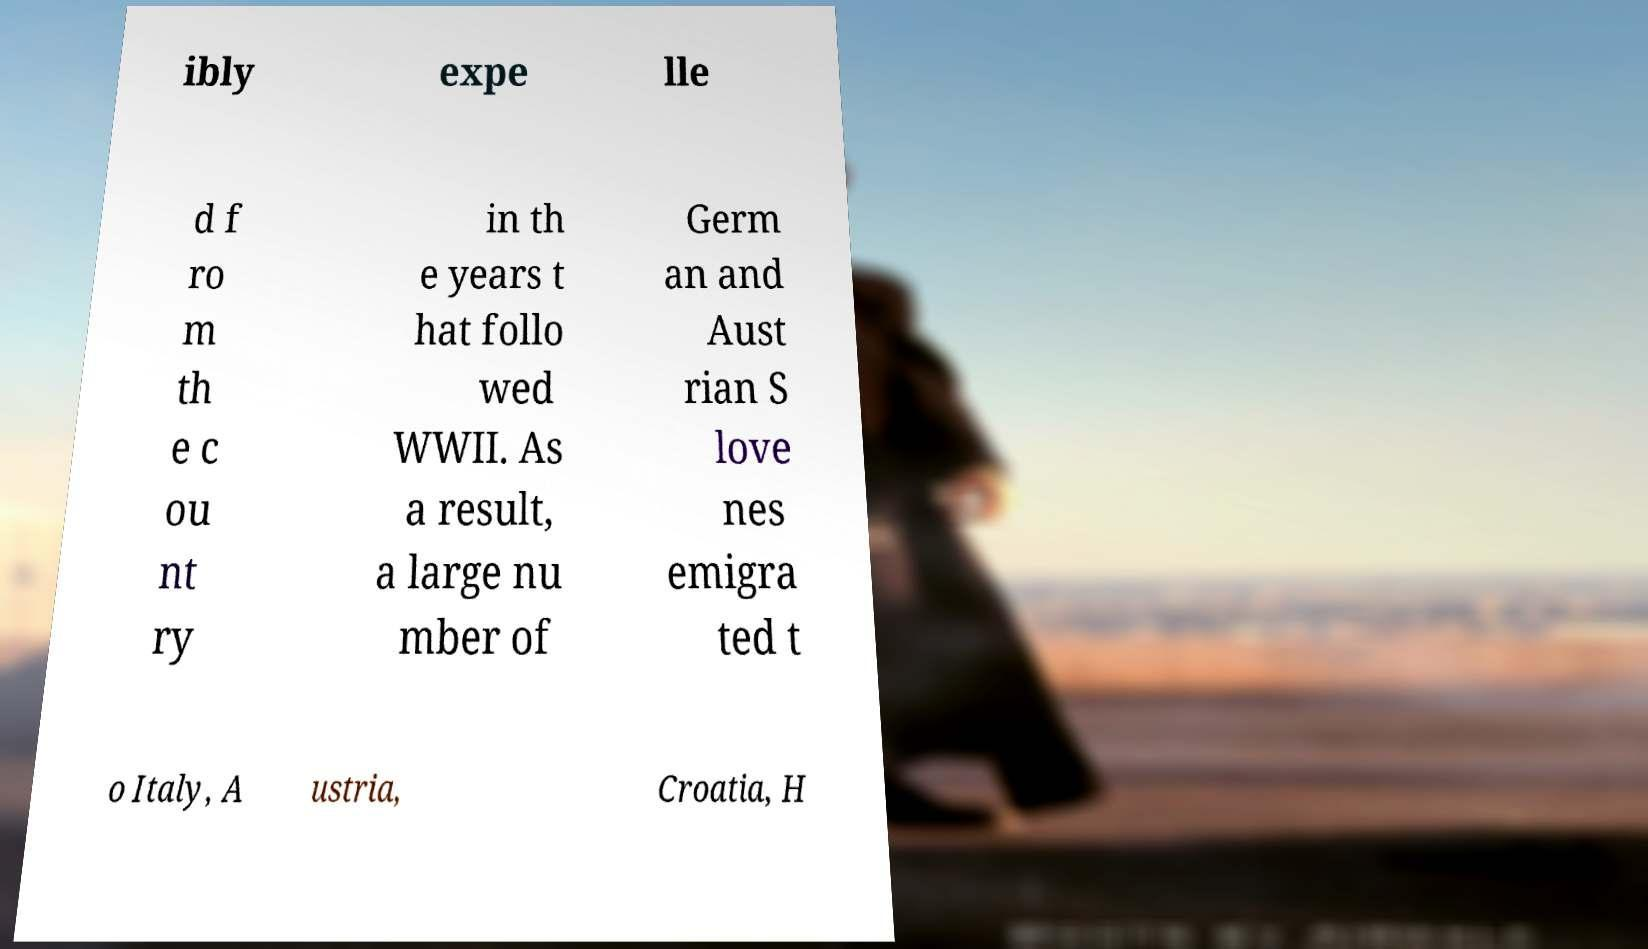Can you read and provide the text displayed in the image?This photo seems to have some interesting text. Can you extract and type it out for me? ibly expe lle d f ro m th e c ou nt ry in th e years t hat follo wed WWII. As a result, a large nu mber of Germ an and Aust rian S love nes emigra ted t o Italy, A ustria, Croatia, H 